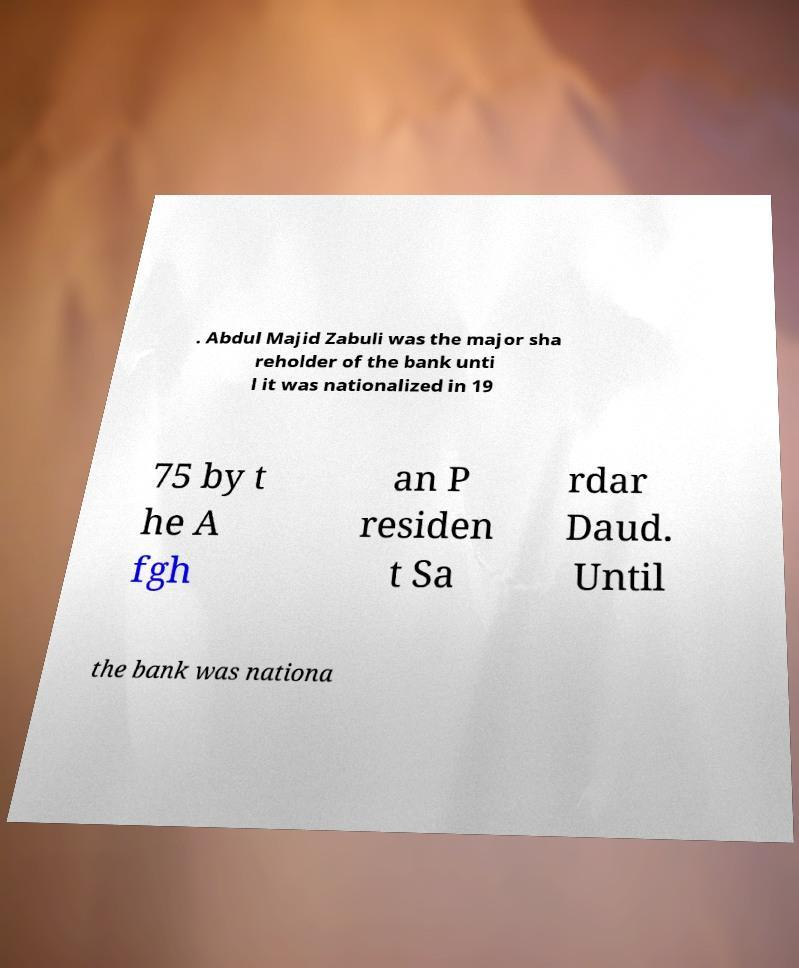There's text embedded in this image that I need extracted. Can you transcribe it verbatim? . Abdul Majid Zabuli was the major sha reholder of the bank unti l it was nationalized in 19 75 by t he A fgh an P residen t Sa rdar Daud. Until the bank was nationa 